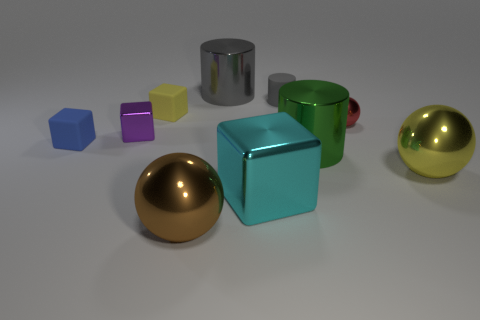There is a large shiny cylinder to the left of the big cyan metal object; how many big balls are behind it?
Make the answer very short. 0. How big is the cube that is behind the yellow metallic sphere and in front of the purple cube?
Ensure brevity in your answer.  Small. There is a yellow thing left of the red object; what is its material?
Provide a short and direct response. Rubber. Is there a small blue object that has the same shape as the cyan object?
Keep it short and to the point. Yes. What number of other large things have the same shape as the big yellow object?
Keep it short and to the point. 1. There is a shiny cube to the left of the tiny yellow matte cube; is it the same size as the matte cylinder that is behind the tiny ball?
Provide a succinct answer. Yes. The big object that is to the right of the tiny metal thing that is to the right of the green metallic object is what shape?
Give a very brief answer. Sphere. Are there the same number of tiny purple objects that are on the right side of the brown sphere and big matte balls?
Your answer should be very brief. Yes. There is a yellow thing to the left of the big ball that is behind the big shiny sphere in front of the yellow sphere; what is its material?
Provide a short and direct response. Rubber. Are there any gray metallic objects of the same size as the brown shiny ball?
Make the answer very short. Yes. 